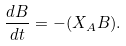<formula> <loc_0><loc_0><loc_500><loc_500>\frac { d B } { d t } = - ( X _ { A } B ) .</formula> 